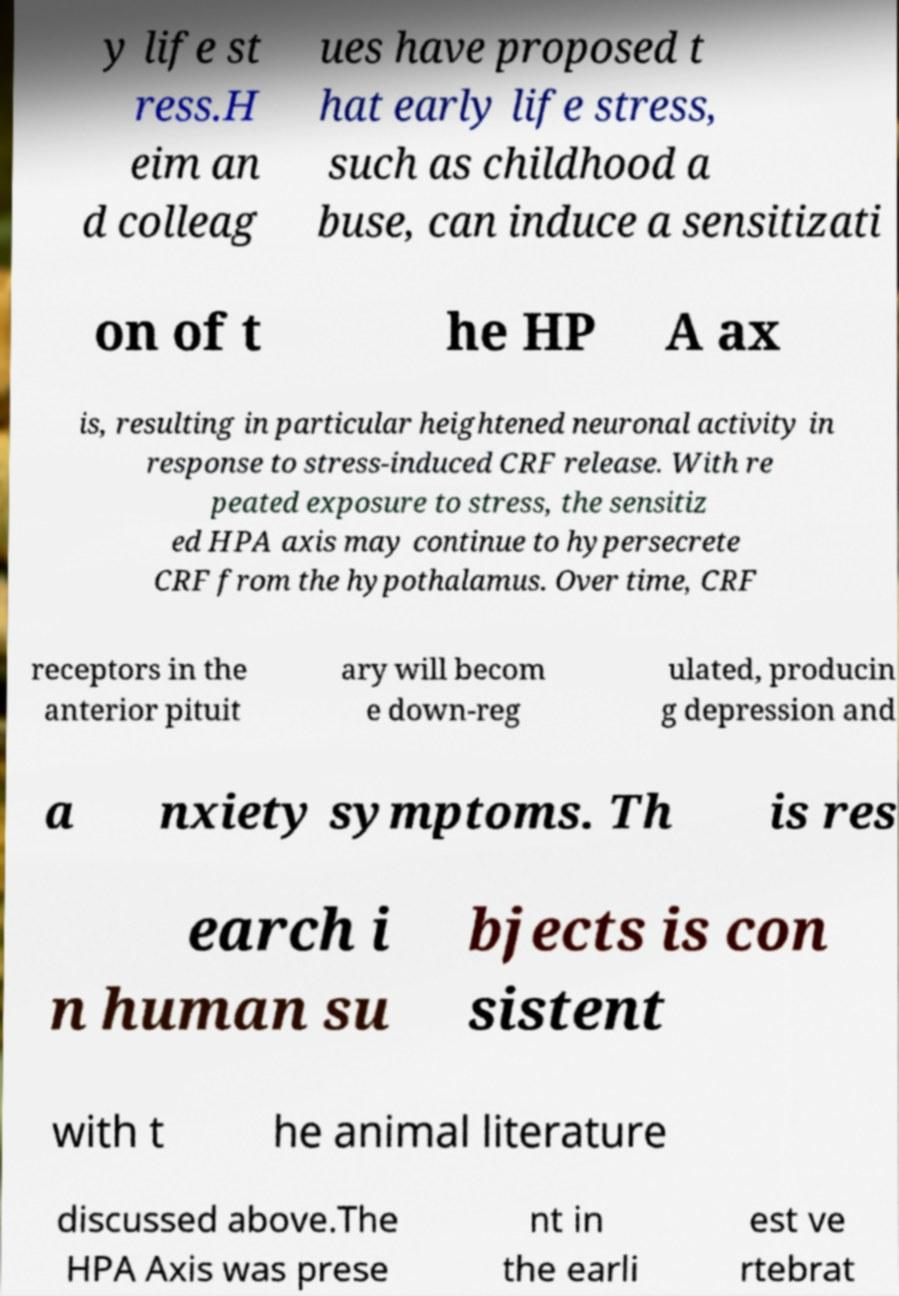There's text embedded in this image that I need extracted. Can you transcribe it verbatim? y life st ress.H eim an d colleag ues have proposed t hat early life stress, such as childhood a buse, can induce a sensitizati on of t he HP A ax is, resulting in particular heightened neuronal activity in response to stress-induced CRF release. With re peated exposure to stress, the sensitiz ed HPA axis may continue to hypersecrete CRF from the hypothalamus. Over time, CRF receptors in the anterior pituit ary will becom e down-reg ulated, producin g depression and a nxiety symptoms. Th is res earch i n human su bjects is con sistent with t he animal literature discussed above.The HPA Axis was prese nt in the earli est ve rtebrat 